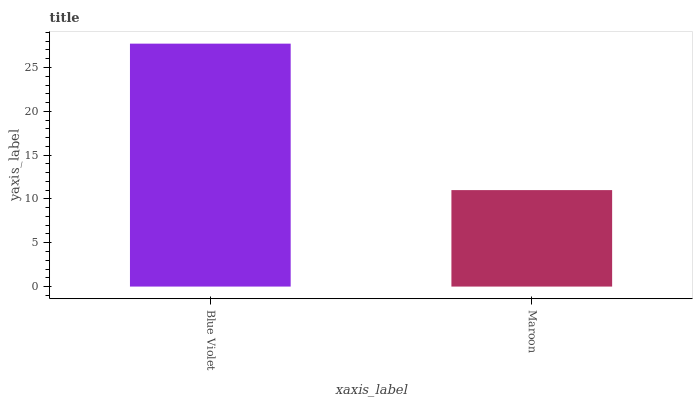Is Maroon the minimum?
Answer yes or no. Yes. Is Blue Violet the maximum?
Answer yes or no. Yes. Is Maroon the maximum?
Answer yes or no. No. Is Blue Violet greater than Maroon?
Answer yes or no. Yes. Is Maroon less than Blue Violet?
Answer yes or no. Yes. Is Maroon greater than Blue Violet?
Answer yes or no. No. Is Blue Violet less than Maroon?
Answer yes or no. No. Is Blue Violet the high median?
Answer yes or no. Yes. Is Maroon the low median?
Answer yes or no. Yes. Is Maroon the high median?
Answer yes or no. No. Is Blue Violet the low median?
Answer yes or no. No. 